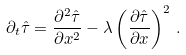Convert formula to latex. <formula><loc_0><loc_0><loc_500><loc_500>\partial _ { t } \hat { \tau } = \frac { \partial ^ { 2 } \hat { \tau } } { \partial x ^ { 2 } } - \lambda \left ( \frac { \partial \hat { \tau } } { \partial x } \right ) ^ { 2 } \, .</formula> 